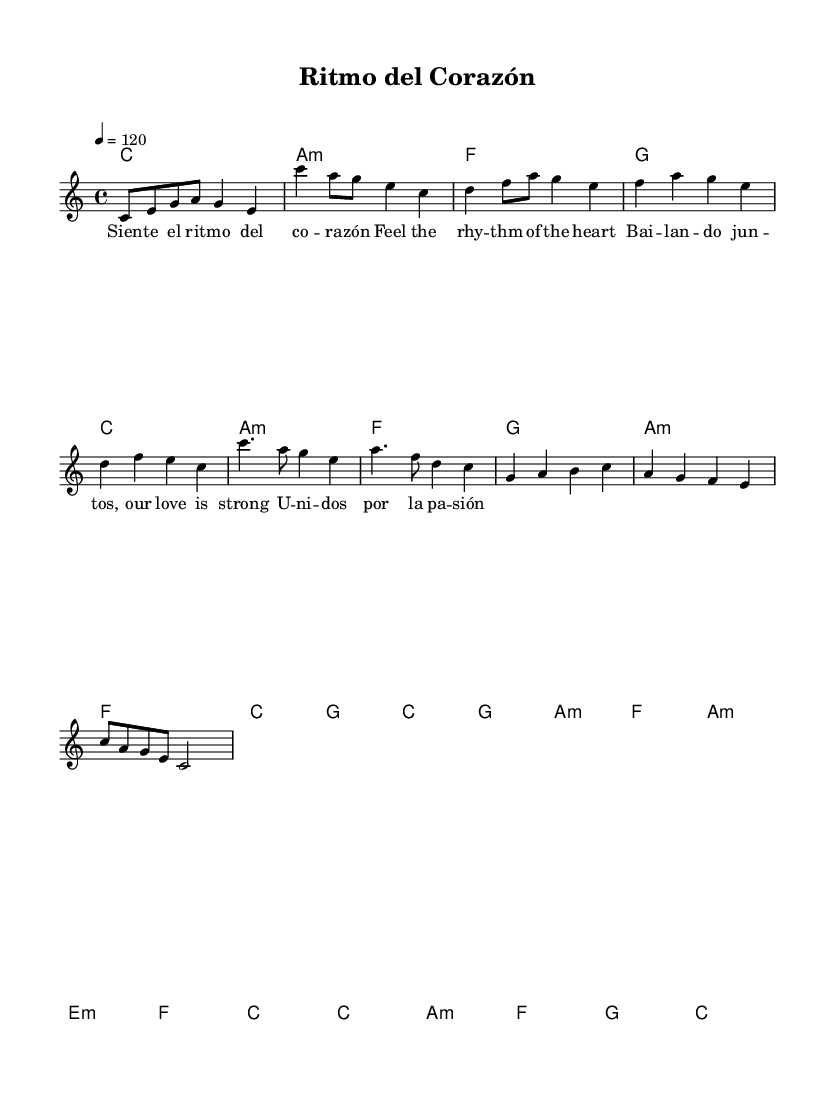What is the key signature of this music? The key signature is C major, which has no sharps or flats.
Answer: C major What is the time signature of this music? The time signature indicated is 4/4, which means there are four beats in each measure.
Answer: 4/4 What is the tempo marking for this piece? The tempo marking indicates a speed of 120 beats per minute, which is generally considered a moderate pace.
Answer: 120 Identify the main chord used in the chorus. The chorus prominently features the C major chord, which is the root chord in this section.
Answer: C How many distinct sections can be identified in the structure of the piece? The structure includes six distinct sections: Intro, Verse, Pre-chorus, Chorus, Bridge, and Outro, each serving a specific purpose.
Answer: Six Why might bilingual lyrics appeal to a broader audience in this music genre? Bilingual lyrics can enhance accessibility, allowing listeners from different linguistic backgrounds to connect with the song, increasing its commercial viability.
Answer: Accessibility 